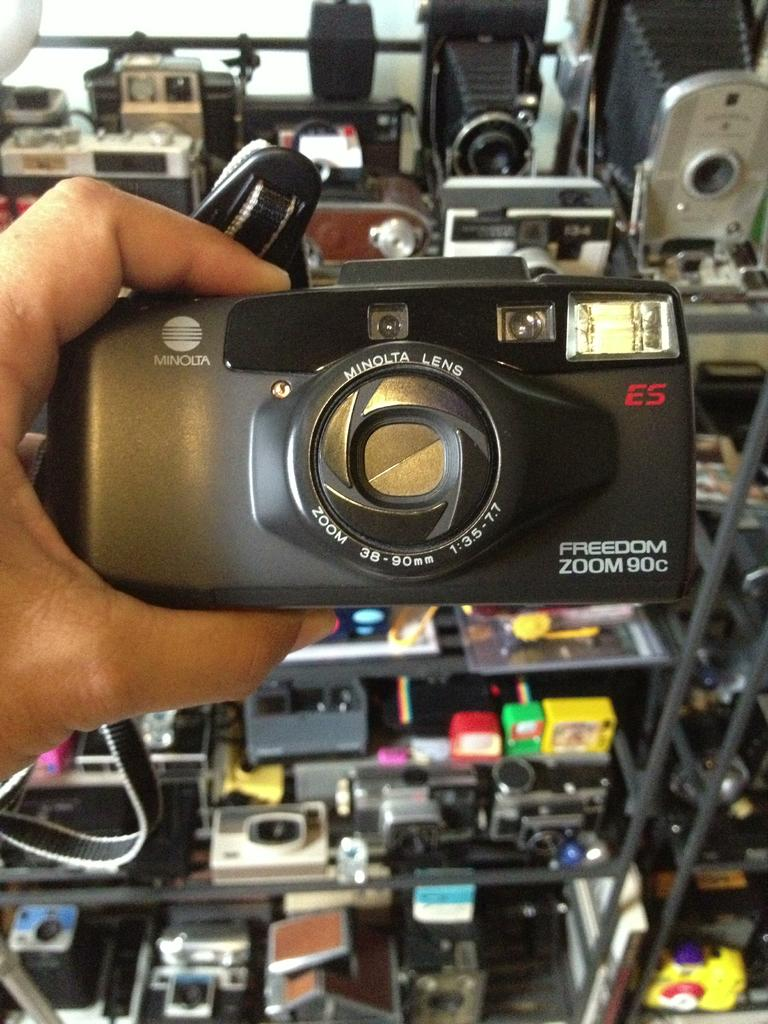What is the person in the image holding? The person in the image is holding a camera. What can be seen in the background of the image? There are racks with cameras in the background of the image. What type of glue is being used to attach the approval sticker to the camera in the image? There is no approval sticker or glue present in the image. 